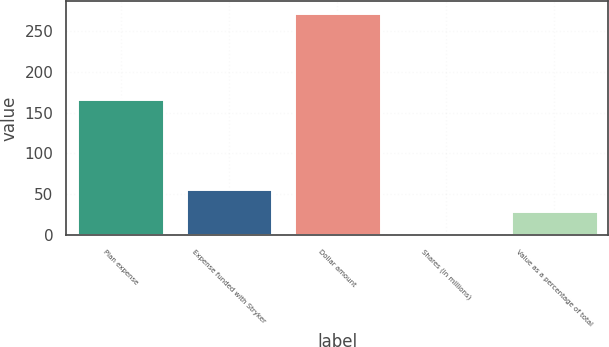<chart> <loc_0><loc_0><loc_500><loc_500><bar_chart><fcel>Plan expense<fcel>Expense funded with Stryker<fcel>Dollar amount<fcel>Shares (in millions)<fcel>Value as a percentage of total<nl><fcel>166<fcel>56.24<fcel>272<fcel>2.3<fcel>29.27<nl></chart> 